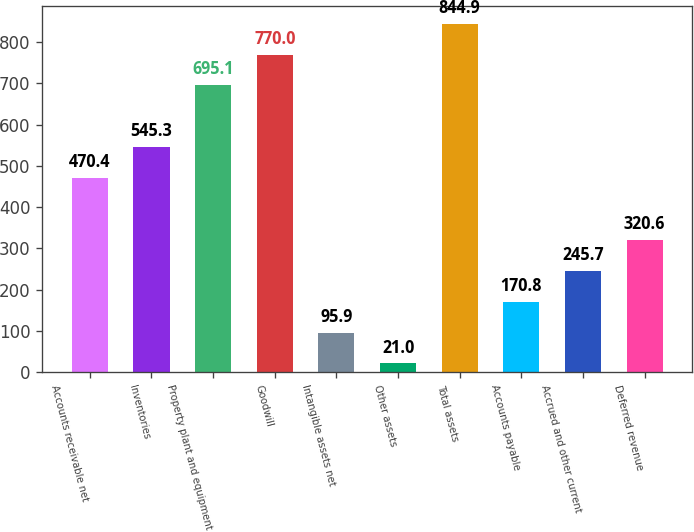Convert chart to OTSL. <chart><loc_0><loc_0><loc_500><loc_500><bar_chart><fcel>Accounts receivable net<fcel>Inventories<fcel>Property plant and equipment<fcel>Goodwill<fcel>Intangible assets net<fcel>Other assets<fcel>Total assets<fcel>Accounts payable<fcel>Accrued and other current<fcel>Deferred revenue<nl><fcel>470.4<fcel>545.3<fcel>695.1<fcel>770<fcel>95.9<fcel>21<fcel>844.9<fcel>170.8<fcel>245.7<fcel>320.6<nl></chart> 